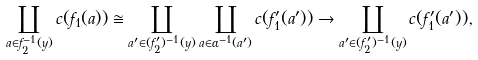<formula> <loc_0><loc_0><loc_500><loc_500>\coprod _ { a \in f _ { 2 } ^ { - 1 } ( y ) } c ( f _ { 1 } ( a ) ) \cong \coprod _ { a ^ { \prime } \in ( f _ { 2 } ^ { \prime } ) ^ { - 1 } ( y ) } \coprod _ { a \in \alpha ^ { - 1 } ( a ^ { \prime } ) } c ( f ^ { \prime } _ { 1 } ( a ^ { \prime } ) ) \to \coprod _ { a ^ { \prime } \in ( f ^ { \prime } _ { 2 } ) ^ { - 1 } ( y ) } c ( f ^ { \prime } _ { 1 } ( a ^ { \prime } ) ) ,</formula> 